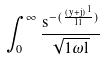Convert formula to latex. <formula><loc_0><loc_0><loc_500><loc_500>\int _ { 0 } ^ { \infty } \frac { s ^ { - ( \frac { ( y + j ) ^ { 1 } } { 1 l } ) } } { \sqrt { 1 \omega l } }</formula> 